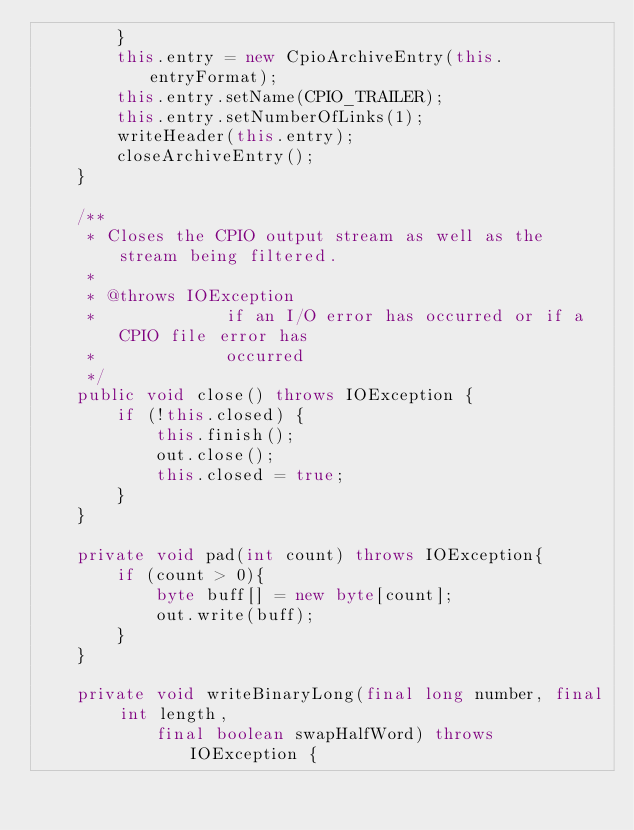<code> <loc_0><loc_0><loc_500><loc_500><_Java_>        }
        this.entry = new CpioArchiveEntry(this.entryFormat);
        this.entry.setName(CPIO_TRAILER);
        this.entry.setNumberOfLinks(1);
        writeHeader(this.entry);
        closeArchiveEntry();
    }

    /**
     * Closes the CPIO output stream as well as the stream being filtered.
     * 
     * @throws IOException
     *             if an I/O error has occurred or if a CPIO file error has
     *             occurred
     */
    public void close() throws IOException {
        if (!this.closed) {
            this.finish();
            out.close();
            this.closed = true;
        }
    }

    private void pad(int count) throws IOException{
        if (count > 0){
            byte buff[] = new byte[count];
            out.write(buff);
        }
    }

    private void writeBinaryLong(final long number, final int length,
            final boolean swapHalfWord) throws IOException {</code> 